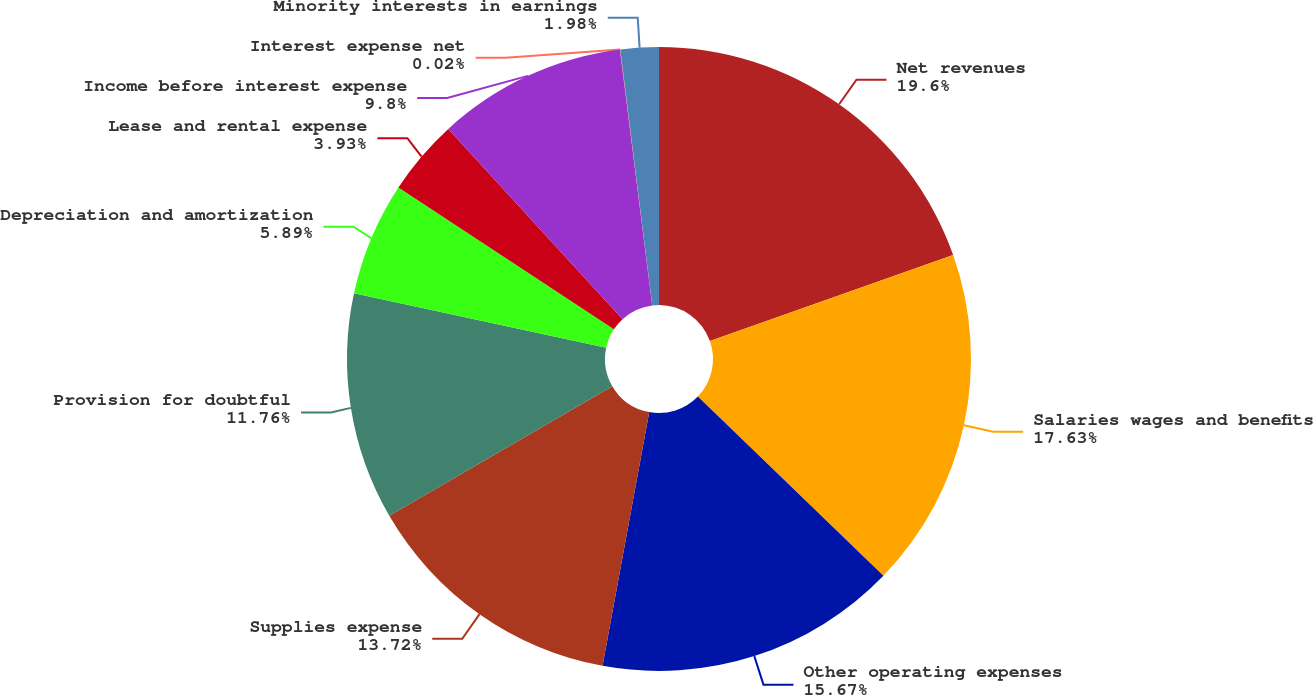<chart> <loc_0><loc_0><loc_500><loc_500><pie_chart><fcel>Net revenues<fcel>Salaries wages and benefits<fcel>Other operating expenses<fcel>Supplies expense<fcel>Provision for doubtful<fcel>Depreciation and amortization<fcel>Lease and rental expense<fcel>Income before interest expense<fcel>Interest expense net<fcel>Minority interests in earnings<nl><fcel>19.59%<fcel>17.63%<fcel>15.67%<fcel>13.72%<fcel>11.76%<fcel>5.89%<fcel>3.93%<fcel>9.8%<fcel>0.02%<fcel>1.98%<nl></chart> 